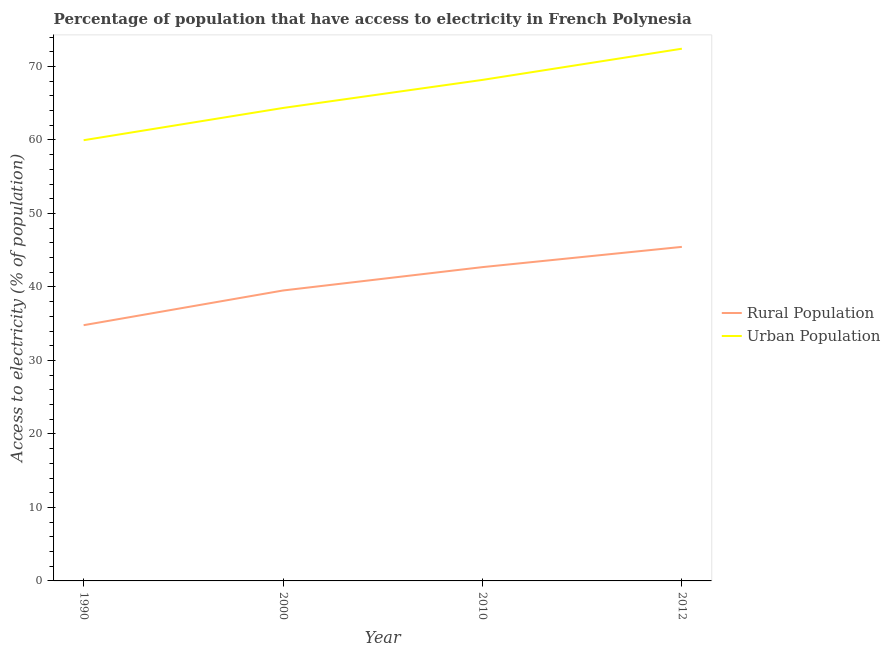How many different coloured lines are there?
Give a very brief answer. 2. What is the percentage of urban population having access to electricity in 2012?
Provide a succinct answer. 72.42. Across all years, what is the maximum percentage of urban population having access to electricity?
Your answer should be very brief. 72.42. Across all years, what is the minimum percentage of rural population having access to electricity?
Make the answer very short. 34.8. In which year was the percentage of rural population having access to electricity minimum?
Make the answer very short. 1990. What is the total percentage of urban population having access to electricity in the graph?
Make the answer very short. 264.92. What is the difference between the percentage of urban population having access to electricity in 1990 and that in 2010?
Your response must be concise. -8.21. What is the difference between the percentage of urban population having access to electricity in 1990 and the percentage of rural population having access to electricity in 2012?
Provide a short and direct response. 14.51. What is the average percentage of urban population having access to electricity per year?
Offer a very short reply. 66.23. In the year 1990, what is the difference between the percentage of urban population having access to electricity and percentage of rural population having access to electricity?
Your response must be concise. 25.17. What is the ratio of the percentage of urban population having access to electricity in 2000 to that in 2012?
Offer a terse response. 0.89. What is the difference between the highest and the second highest percentage of rural population having access to electricity?
Your answer should be compact. 2.75. What is the difference between the highest and the lowest percentage of rural population having access to electricity?
Your answer should be very brief. 10.66. Is the percentage of urban population having access to electricity strictly greater than the percentage of rural population having access to electricity over the years?
Your answer should be very brief. Yes. How many lines are there?
Your answer should be compact. 2. How many years are there in the graph?
Your answer should be very brief. 4. What is the difference between two consecutive major ticks on the Y-axis?
Provide a short and direct response. 10. Does the graph contain any zero values?
Keep it short and to the point. No. How many legend labels are there?
Offer a terse response. 2. What is the title of the graph?
Offer a terse response. Percentage of population that have access to electricity in French Polynesia. Does "Personal remittances" appear as one of the legend labels in the graph?
Give a very brief answer. No. What is the label or title of the Y-axis?
Provide a short and direct response. Access to electricity (% of population). What is the Access to electricity (% of population) in Rural Population in 1990?
Your answer should be very brief. 34.8. What is the Access to electricity (% of population) of Urban Population in 1990?
Provide a short and direct response. 59.97. What is the Access to electricity (% of population) of Rural Population in 2000?
Keep it short and to the point. 39.52. What is the Access to electricity (% of population) of Urban Population in 2000?
Keep it short and to the point. 64.36. What is the Access to electricity (% of population) of Rural Population in 2010?
Your answer should be very brief. 42.7. What is the Access to electricity (% of population) in Urban Population in 2010?
Ensure brevity in your answer.  68.18. What is the Access to electricity (% of population) in Rural Population in 2012?
Your answer should be very brief. 45.45. What is the Access to electricity (% of population) of Urban Population in 2012?
Provide a succinct answer. 72.42. Across all years, what is the maximum Access to electricity (% of population) of Rural Population?
Offer a terse response. 45.45. Across all years, what is the maximum Access to electricity (% of population) in Urban Population?
Provide a succinct answer. 72.42. Across all years, what is the minimum Access to electricity (% of population) in Rural Population?
Provide a short and direct response. 34.8. Across all years, what is the minimum Access to electricity (% of population) in Urban Population?
Offer a very short reply. 59.97. What is the total Access to electricity (% of population) of Rural Population in the graph?
Make the answer very short. 162.47. What is the total Access to electricity (% of population) in Urban Population in the graph?
Your response must be concise. 264.92. What is the difference between the Access to electricity (% of population) in Rural Population in 1990 and that in 2000?
Give a very brief answer. -4.72. What is the difference between the Access to electricity (% of population) of Urban Population in 1990 and that in 2000?
Your response must be concise. -4.39. What is the difference between the Access to electricity (% of population) in Rural Population in 1990 and that in 2010?
Your answer should be compact. -7.9. What is the difference between the Access to electricity (% of population) in Urban Population in 1990 and that in 2010?
Your response must be concise. -8.21. What is the difference between the Access to electricity (% of population) of Rural Population in 1990 and that in 2012?
Ensure brevity in your answer.  -10.66. What is the difference between the Access to electricity (% of population) in Urban Population in 1990 and that in 2012?
Offer a terse response. -12.45. What is the difference between the Access to electricity (% of population) in Rural Population in 2000 and that in 2010?
Provide a short and direct response. -3.18. What is the difference between the Access to electricity (% of population) in Urban Population in 2000 and that in 2010?
Make the answer very short. -3.82. What is the difference between the Access to electricity (% of population) in Rural Population in 2000 and that in 2012?
Your response must be concise. -5.93. What is the difference between the Access to electricity (% of population) in Urban Population in 2000 and that in 2012?
Your response must be concise. -8.06. What is the difference between the Access to electricity (% of population) of Rural Population in 2010 and that in 2012?
Your response must be concise. -2.75. What is the difference between the Access to electricity (% of population) of Urban Population in 2010 and that in 2012?
Provide a short and direct response. -4.25. What is the difference between the Access to electricity (% of population) of Rural Population in 1990 and the Access to electricity (% of population) of Urban Population in 2000?
Give a very brief answer. -29.56. What is the difference between the Access to electricity (% of population) of Rural Population in 1990 and the Access to electricity (% of population) of Urban Population in 2010?
Your answer should be very brief. -33.38. What is the difference between the Access to electricity (% of population) in Rural Population in 1990 and the Access to electricity (% of population) in Urban Population in 2012?
Keep it short and to the point. -37.62. What is the difference between the Access to electricity (% of population) of Rural Population in 2000 and the Access to electricity (% of population) of Urban Population in 2010?
Give a very brief answer. -28.66. What is the difference between the Access to electricity (% of population) in Rural Population in 2000 and the Access to electricity (% of population) in Urban Population in 2012?
Provide a succinct answer. -32.9. What is the difference between the Access to electricity (% of population) in Rural Population in 2010 and the Access to electricity (% of population) in Urban Population in 2012?
Your response must be concise. -29.72. What is the average Access to electricity (% of population) of Rural Population per year?
Provide a short and direct response. 40.62. What is the average Access to electricity (% of population) in Urban Population per year?
Offer a terse response. 66.23. In the year 1990, what is the difference between the Access to electricity (% of population) in Rural Population and Access to electricity (% of population) in Urban Population?
Your answer should be compact. -25.17. In the year 2000, what is the difference between the Access to electricity (% of population) in Rural Population and Access to electricity (% of population) in Urban Population?
Provide a succinct answer. -24.84. In the year 2010, what is the difference between the Access to electricity (% of population) in Rural Population and Access to electricity (% of population) in Urban Population?
Give a very brief answer. -25.48. In the year 2012, what is the difference between the Access to electricity (% of population) of Rural Population and Access to electricity (% of population) of Urban Population?
Give a very brief answer. -26.97. What is the ratio of the Access to electricity (% of population) in Rural Population in 1990 to that in 2000?
Your answer should be compact. 0.88. What is the ratio of the Access to electricity (% of population) of Urban Population in 1990 to that in 2000?
Give a very brief answer. 0.93. What is the ratio of the Access to electricity (% of population) in Rural Population in 1990 to that in 2010?
Ensure brevity in your answer.  0.81. What is the ratio of the Access to electricity (% of population) of Urban Population in 1990 to that in 2010?
Ensure brevity in your answer.  0.88. What is the ratio of the Access to electricity (% of population) of Rural Population in 1990 to that in 2012?
Give a very brief answer. 0.77. What is the ratio of the Access to electricity (% of population) in Urban Population in 1990 to that in 2012?
Provide a succinct answer. 0.83. What is the ratio of the Access to electricity (% of population) of Rural Population in 2000 to that in 2010?
Ensure brevity in your answer.  0.93. What is the ratio of the Access to electricity (% of population) of Urban Population in 2000 to that in 2010?
Give a very brief answer. 0.94. What is the ratio of the Access to electricity (% of population) in Rural Population in 2000 to that in 2012?
Provide a succinct answer. 0.87. What is the ratio of the Access to electricity (% of population) of Urban Population in 2000 to that in 2012?
Make the answer very short. 0.89. What is the ratio of the Access to electricity (% of population) in Rural Population in 2010 to that in 2012?
Offer a very short reply. 0.94. What is the ratio of the Access to electricity (% of population) of Urban Population in 2010 to that in 2012?
Your answer should be very brief. 0.94. What is the difference between the highest and the second highest Access to electricity (% of population) in Rural Population?
Ensure brevity in your answer.  2.75. What is the difference between the highest and the second highest Access to electricity (% of population) of Urban Population?
Keep it short and to the point. 4.25. What is the difference between the highest and the lowest Access to electricity (% of population) in Rural Population?
Provide a short and direct response. 10.66. What is the difference between the highest and the lowest Access to electricity (% of population) in Urban Population?
Provide a succinct answer. 12.45. 